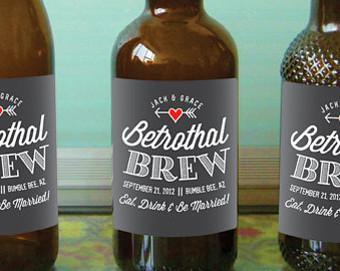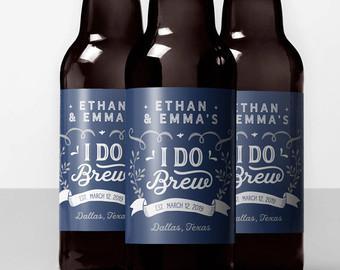The first image is the image on the left, the second image is the image on the right. For the images displayed, is the sentence "An image features exactly four bottles in a row." factually correct? Answer yes or no. No. 